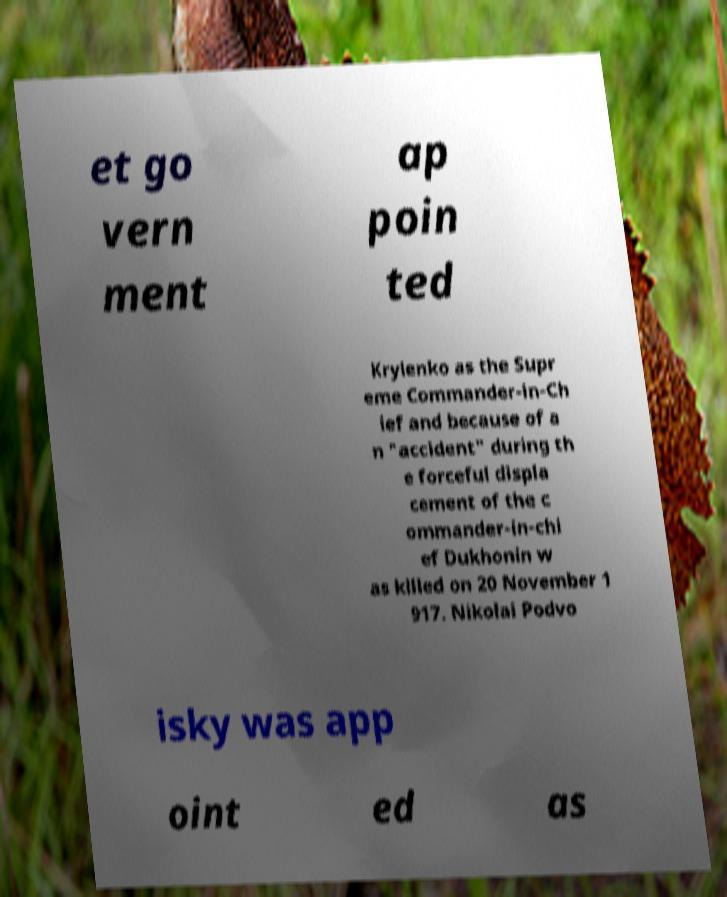There's text embedded in this image that I need extracted. Can you transcribe it verbatim? et go vern ment ap poin ted Krylenko as the Supr eme Commander-in-Ch ief and because of a n "accident" during th e forceful displa cement of the c ommander-in-chi ef Dukhonin w as killed on 20 November 1 917. Nikolai Podvo isky was app oint ed as 